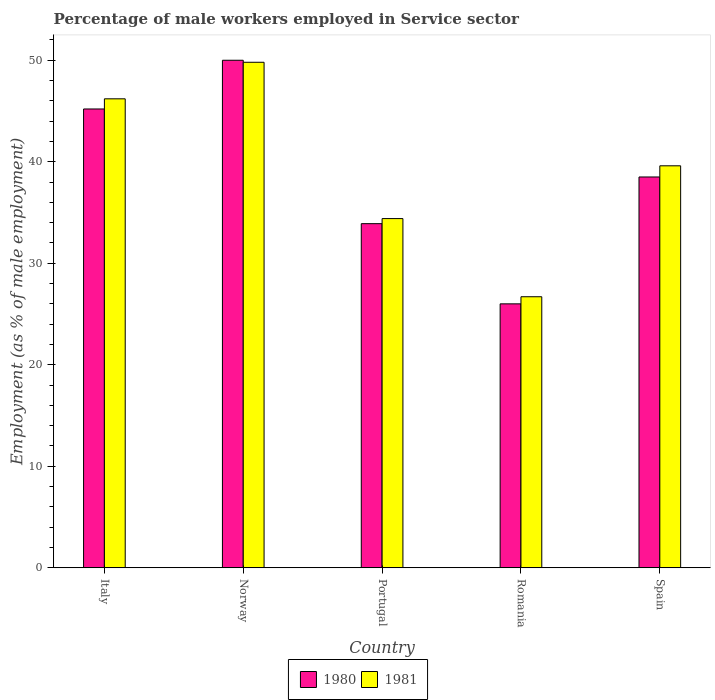How many different coloured bars are there?
Your response must be concise. 2. Are the number of bars on each tick of the X-axis equal?
Give a very brief answer. Yes. How many bars are there on the 3rd tick from the right?
Your answer should be compact. 2. What is the percentage of male workers employed in Service sector in 1980 in Norway?
Keep it short and to the point. 50. Across all countries, what is the minimum percentage of male workers employed in Service sector in 1980?
Offer a very short reply. 26. In which country was the percentage of male workers employed in Service sector in 1981 minimum?
Your answer should be compact. Romania. What is the total percentage of male workers employed in Service sector in 1980 in the graph?
Offer a very short reply. 193.6. What is the difference between the percentage of male workers employed in Service sector in 1980 in Italy and that in Romania?
Your response must be concise. 19.2. What is the difference between the percentage of male workers employed in Service sector in 1980 in Norway and the percentage of male workers employed in Service sector in 1981 in Spain?
Keep it short and to the point. 10.4. What is the average percentage of male workers employed in Service sector in 1980 per country?
Provide a succinct answer. 38.72. What is the difference between the percentage of male workers employed in Service sector of/in 1981 and percentage of male workers employed in Service sector of/in 1980 in Spain?
Make the answer very short. 1.1. In how many countries, is the percentage of male workers employed in Service sector in 1980 greater than 40 %?
Offer a very short reply. 2. What is the ratio of the percentage of male workers employed in Service sector in 1980 in Norway to that in Portugal?
Ensure brevity in your answer.  1.47. Is the difference between the percentage of male workers employed in Service sector in 1981 in Italy and Norway greater than the difference between the percentage of male workers employed in Service sector in 1980 in Italy and Norway?
Your answer should be compact. Yes. What is the difference between the highest and the second highest percentage of male workers employed in Service sector in 1980?
Offer a very short reply. 4.8. In how many countries, is the percentage of male workers employed in Service sector in 1981 greater than the average percentage of male workers employed in Service sector in 1981 taken over all countries?
Make the answer very short. 3. What does the 1st bar from the left in Romania represents?
Offer a very short reply. 1980. What does the 2nd bar from the right in Spain represents?
Provide a succinct answer. 1980. How many bars are there?
Provide a short and direct response. 10. Are all the bars in the graph horizontal?
Offer a very short reply. No. How many countries are there in the graph?
Make the answer very short. 5. Does the graph contain any zero values?
Offer a terse response. No. Does the graph contain grids?
Offer a terse response. No. How many legend labels are there?
Provide a succinct answer. 2. How are the legend labels stacked?
Keep it short and to the point. Horizontal. What is the title of the graph?
Offer a terse response. Percentage of male workers employed in Service sector. What is the label or title of the X-axis?
Offer a terse response. Country. What is the label or title of the Y-axis?
Provide a short and direct response. Employment (as % of male employment). What is the Employment (as % of male employment) of 1980 in Italy?
Make the answer very short. 45.2. What is the Employment (as % of male employment) in 1981 in Italy?
Offer a very short reply. 46.2. What is the Employment (as % of male employment) of 1981 in Norway?
Your response must be concise. 49.8. What is the Employment (as % of male employment) in 1980 in Portugal?
Ensure brevity in your answer.  33.9. What is the Employment (as % of male employment) of 1981 in Portugal?
Provide a short and direct response. 34.4. What is the Employment (as % of male employment) of 1981 in Romania?
Offer a very short reply. 26.7. What is the Employment (as % of male employment) in 1980 in Spain?
Provide a succinct answer. 38.5. What is the Employment (as % of male employment) of 1981 in Spain?
Your answer should be very brief. 39.6. Across all countries, what is the maximum Employment (as % of male employment) in 1981?
Provide a succinct answer. 49.8. Across all countries, what is the minimum Employment (as % of male employment) of 1980?
Provide a short and direct response. 26. Across all countries, what is the minimum Employment (as % of male employment) in 1981?
Provide a succinct answer. 26.7. What is the total Employment (as % of male employment) in 1980 in the graph?
Your answer should be very brief. 193.6. What is the total Employment (as % of male employment) of 1981 in the graph?
Offer a very short reply. 196.7. What is the difference between the Employment (as % of male employment) of 1980 in Italy and that in Norway?
Offer a terse response. -4.8. What is the difference between the Employment (as % of male employment) of 1981 in Italy and that in Portugal?
Your answer should be very brief. 11.8. What is the difference between the Employment (as % of male employment) of 1980 in Italy and that in Romania?
Your answer should be very brief. 19.2. What is the difference between the Employment (as % of male employment) in 1981 in Italy and that in Romania?
Ensure brevity in your answer.  19.5. What is the difference between the Employment (as % of male employment) in 1981 in Norway and that in Portugal?
Give a very brief answer. 15.4. What is the difference between the Employment (as % of male employment) in 1981 in Norway and that in Romania?
Your response must be concise. 23.1. What is the difference between the Employment (as % of male employment) of 1981 in Norway and that in Spain?
Give a very brief answer. 10.2. What is the difference between the Employment (as % of male employment) in 1980 in Portugal and that in Romania?
Your answer should be compact. 7.9. What is the difference between the Employment (as % of male employment) of 1981 in Portugal and that in Romania?
Provide a succinct answer. 7.7. What is the difference between the Employment (as % of male employment) in 1980 in Portugal and that in Spain?
Your response must be concise. -4.6. What is the difference between the Employment (as % of male employment) of 1980 in Romania and that in Spain?
Provide a short and direct response. -12.5. What is the difference between the Employment (as % of male employment) of 1981 in Romania and that in Spain?
Your answer should be compact. -12.9. What is the difference between the Employment (as % of male employment) of 1980 in Italy and the Employment (as % of male employment) of 1981 in Norway?
Offer a very short reply. -4.6. What is the difference between the Employment (as % of male employment) of 1980 in Italy and the Employment (as % of male employment) of 1981 in Romania?
Your answer should be compact. 18.5. What is the difference between the Employment (as % of male employment) of 1980 in Italy and the Employment (as % of male employment) of 1981 in Spain?
Make the answer very short. 5.6. What is the difference between the Employment (as % of male employment) of 1980 in Norway and the Employment (as % of male employment) of 1981 in Portugal?
Keep it short and to the point. 15.6. What is the difference between the Employment (as % of male employment) of 1980 in Norway and the Employment (as % of male employment) of 1981 in Romania?
Your answer should be very brief. 23.3. What is the difference between the Employment (as % of male employment) in 1980 in Romania and the Employment (as % of male employment) in 1981 in Spain?
Offer a terse response. -13.6. What is the average Employment (as % of male employment) of 1980 per country?
Keep it short and to the point. 38.72. What is the average Employment (as % of male employment) in 1981 per country?
Provide a succinct answer. 39.34. What is the difference between the Employment (as % of male employment) in 1980 and Employment (as % of male employment) in 1981 in Italy?
Provide a short and direct response. -1. What is the difference between the Employment (as % of male employment) of 1980 and Employment (as % of male employment) of 1981 in Norway?
Provide a short and direct response. 0.2. What is the difference between the Employment (as % of male employment) in 1980 and Employment (as % of male employment) in 1981 in Romania?
Your answer should be very brief. -0.7. What is the ratio of the Employment (as % of male employment) of 1980 in Italy to that in Norway?
Offer a very short reply. 0.9. What is the ratio of the Employment (as % of male employment) in 1981 in Italy to that in Norway?
Provide a succinct answer. 0.93. What is the ratio of the Employment (as % of male employment) of 1981 in Italy to that in Portugal?
Offer a terse response. 1.34. What is the ratio of the Employment (as % of male employment) of 1980 in Italy to that in Romania?
Ensure brevity in your answer.  1.74. What is the ratio of the Employment (as % of male employment) of 1981 in Italy to that in Romania?
Provide a short and direct response. 1.73. What is the ratio of the Employment (as % of male employment) in 1980 in Italy to that in Spain?
Make the answer very short. 1.17. What is the ratio of the Employment (as % of male employment) of 1981 in Italy to that in Spain?
Ensure brevity in your answer.  1.17. What is the ratio of the Employment (as % of male employment) in 1980 in Norway to that in Portugal?
Offer a very short reply. 1.47. What is the ratio of the Employment (as % of male employment) in 1981 in Norway to that in Portugal?
Your answer should be very brief. 1.45. What is the ratio of the Employment (as % of male employment) in 1980 in Norway to that in Romania?
Offer a very short reply. 1.92. What is the ratio of the Employment (as % of male employment) of 1981 in Norway to that in Romania?
Provide a short and direct response. 1.87. What is the ratio of the Employment (as % of male employment) in 1980 in Norway to that in Spain?
Your answer should be very brief. 1.3. What is the ratio of the Employment (as % of male employment) in 1981 in Norway to that in Spain?
Make the answer very short. 1.26. What is the ratio of the Employment (as % of male employment) in 1980 in Portugal to that in Romania?
Ensure brevity in your answer.  1.3. What is the ratio of the Employment (as % of male employment) in 1981 in Portugal to that in Romania?
Your answer should be compact. 1.29. What is the ratio of the Employment (as % of male employment) in 1980 in Portugal to that in Spain?
Your answer should be very brief. 0.88. What is the ratio of the Employment (as % of male employment) in 1981 in Portugal to that in Spain?
Your answer should be compact. 0.87. What is the ratio of the Employment (as % of male employment) in 1980 in Romania to that in Spain?
Your answer should be compact. 0.68. What is the ratio of the Employment (as % of male employment) in 1981 in Romania to that in Spain?
Give a very brief answer. 0.67. What is the difference between the highest and the second highest Employment (as % of male employment) in 1980?
Give a very brief answer. 4.8. What is the difference between the highest and the lowest Employment (as % of male employment) in 1980?
Your response must be concise. 24. What is the difference between the highest and the lowest Employment (as % of male employment) in 1981?
Offer a terse response. 23.1. 